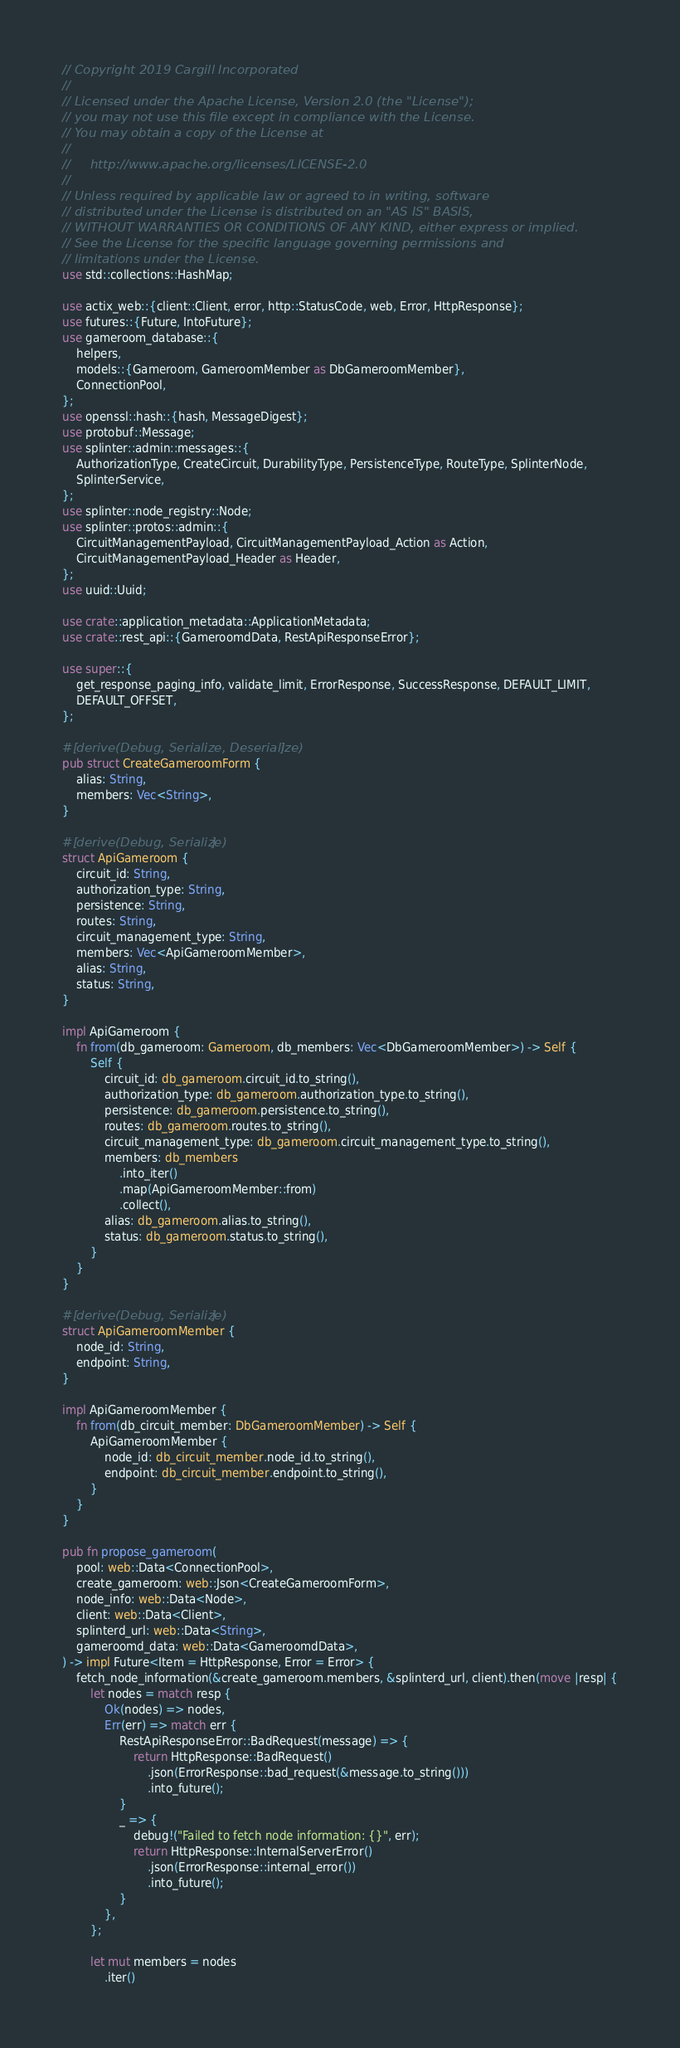<code> <loc_0><loc_0><loc_500><loc_500><_Rust_>// Copyright 2019 Cargill Incorporated
//
// Licensed under the Apache License, Version 2.0 (the "License");
// you may not use this file except in compliance with the License.
// You may obtain a copy of the License at
//
//     http://www.apache.org/licenses/LICENSE-2.0
//
// Unless required by applicable law or agreed to in writing, software
// distributed under the License is distributed on an "AS IS" BASIS,
// WITHOUT WARRANTIES OR CONDITIONS OF ANY KIND, either express or implied.
// See the License for the specific language governing permissions and
// limitations under the License.
use std::collections::HashMap;

use actix_web::{client::Client, error, http::StatusCode, web, Error, HttpResponse};
use futures::{Future, IntoFuture};
use gameroom_database::{
    helpers,
    models::{Gameroom, GameroomMember as DbGameroomMember},
    ConnectionPool,
};
use openssl::hash::{hash, MessageDigest};
use protobuf::Message;
use splinter::admin::messages::{
    AuthorizationType, CreateCircuit, DurabilityType, PersistenceType, RouteType, SplinterNode,
    SplinterService,
};
use splinter::node_registry::Node;
use splinter::protos::admin::{
    CircuitManagementPayload, CircuitManagementPayload_Action as Action,
    CircuitManagementPayload_Header as Header,
};
use uuid::Uuid;

use crate::application_metadata::ApplicationMetadata;
use crate::rest_api::{GameroomdData, RestApiResponseError};

use super::{
    get_response_paging_info, validate_limit, ErrorResponse, SuccessResponse, DEFAULT_LIMIT,
    DEFAULT_OFFSET,
};

#[derive(Debug, Serialize, Deserialize)]
pub struct CreateGameroomForm {
    alias: String,
    members: Vec<String>,
}

#[derive(Debug, Serialize)]
struct ApiGameroom {
    circuit_id: String,
    authorization_type: String,
    persistence: String,
    routes: String,
    circuit_management_type: String,
    members: Vec<ApiGameroomMember>,
    alias: String,
    status: String,
}

impl ApiGameroom {
    fn from(db_gameroom: Gameroom, db_members: Vec<DbGameroomMember>) -> Self {
        Self {
            circuit_id: db_gameroom.circuit_id.to_string(),
            authorization_type: db_gameroom.authorization_type.to_string(),
            persistence: db_gameroom.persistence.to_string(),
            routes: db_gameroom.routes.to_string(),
            circuit_management_type: db_gameroom.circuit_management_type.to_string(),
            members: db_members
                .into_iter()
                .map(ApiGameroomMember::from)
                .collect(),
            alias: db_gameroom.alias.to_string(),
            status: db_gameroom.status.to_string(),
        }
    }
}

#[derive(Debug, Serialize)]
struct ApiGameroomMember {
    node_id: String,
    endpoint: String,
}

impl ApiGameroomMember {
    fn from(db_circuit_member: DbGameroomMember) -> Self {
        ApiGameroomMember {
            node_id: db_circuit_member.node_id.to_string(),
            endpoint: db_circuit_member.endpoint.to_string(),
        }
    }
}

pub fn propose_gameroom(
    pool: web::Data<ConnectionPool>,
    create_gameroom: web::Json<CreateGameroomForm>,
    node_info: web::Data<Node>,
    client: web::Data<Client>,
    splinterd_url: web::Data<String>,
    gameroomd_data: web::Data<GameroomdData>,
) -> impl Future<Item = HttpResponse, Error = Error> {
    fetch_node_information(&create_gameroom.members, &splinterd_url, client).then(move |resp| {
        let nodes = match resp {
            Ok(nodes) => nodes,
            Err(err) => match err {
                RestApiResponseError::BadRequest(message) => {
                    return HttpResponse::BadRequest()
                        .json(ErrorResponse::bad_request(&message.to_string()))
                        .into_future();
                }
                _ => {
                    debug!("Failed to fetch node information: {}", err);
                    return HttpResponse::InternalServerError()
                        .json(ErrorResponse::internal_error())
                        .into_future();
                }
            },
        };

        let mut members = nodes
            .iter()</code> 